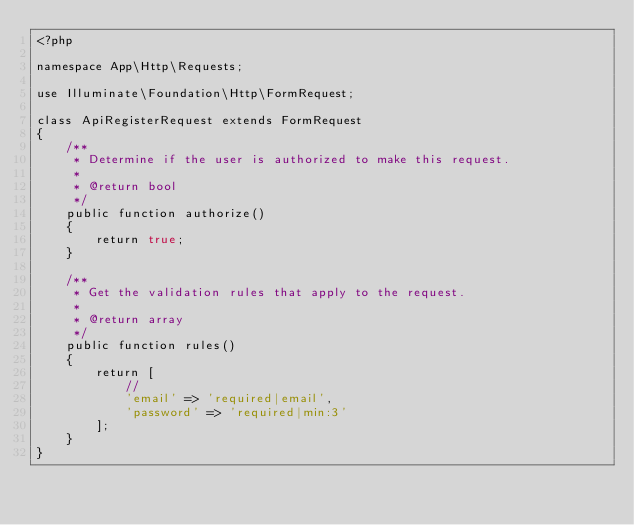Convert code to text. <code><loc_0><loc_0><loc_500><loc_500><_PHP_><?php

namespace App\Http\Requests;

use Illuminate\Foundation\Http\FormRequest;

class ApiRegisterRequest extends FormRequest
{
    /**
     * Determine if the user is authorized to make this request.
     *
     * @return bool
     */
    public function authorize()
    {
        return true;
    }

    /**
     * Get the validation rules that apply to the request.
     *
     * @return array
     */
    public function rules()
    {
        return [
            //
            'email' => 'required|email',
            'password' => 'required|min:3' 
        ];
    }
}
</code> 